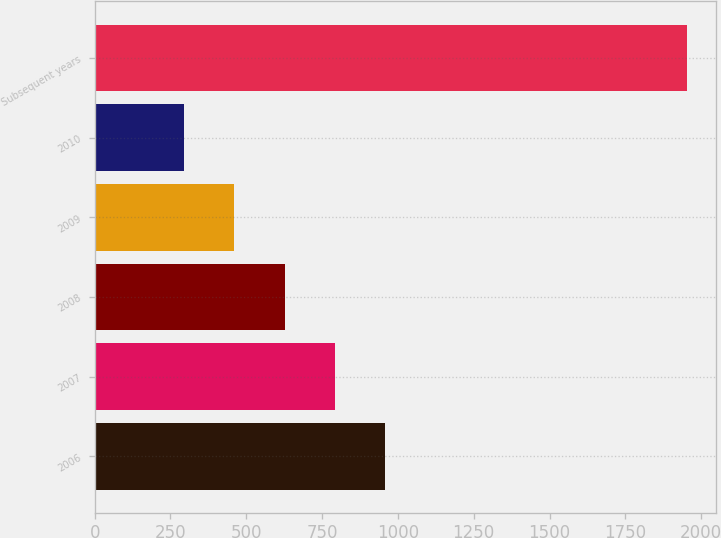<chart> <loc_0><loc_0><loc_500><loc_500><bar_chart><fcel>2006<fcel>2007<fcel>2008<fcel>2009<fcel>2010<fcel>Subsequent years<nl><fcel>957.8<fcel>792.1<fcel>626.4<fcel>460.7<fcel>295<fcel>1952<nl></chart> 